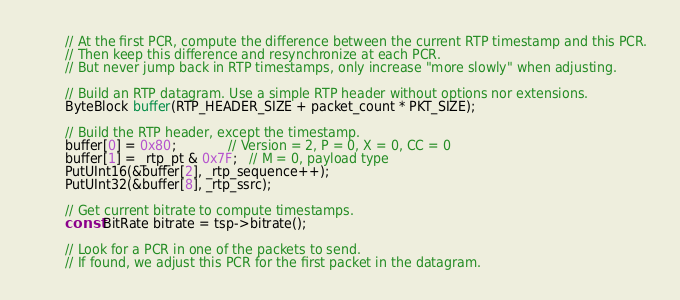Convert code to text. <code><loc_0><loc_0><loc_500><loc_500><_C++_>        // At the first PCR, compute the difference between the current RTP timestamp and this PCR.
        // Then keep this difference and resynchronize at each PCR.
        // But never jump back in RTP timestamps, only increase "more slowly" when adjusting.

        // Build an RTP datagram. Use a simple RTP header without options nor extensions.
        ByteBlock buffer(RTP_HEADER_SIZE + packet_count * PKT_SIZE);

        // Build the RTP header, except the timestamp.
        buffer[0] = 0x80;             // Version = 2, P = 0, X = 0, CC = 0
        buffer[1] = _rtp_pt & 0x7F;   // M = 0, payload type
        PutUInt16(&buffer[2], _rtp_sequence++);
        PutUInt32(&buffer[8], _rtp_ssrc);

        // Get current bitrate to compute timestamps.
        const BitRate bitrate = tsp->bitrate();

        // Look for a PCR in one of the packets to send.
        // If found, we adjust this PCR for the first packet in the datagram.</code> 